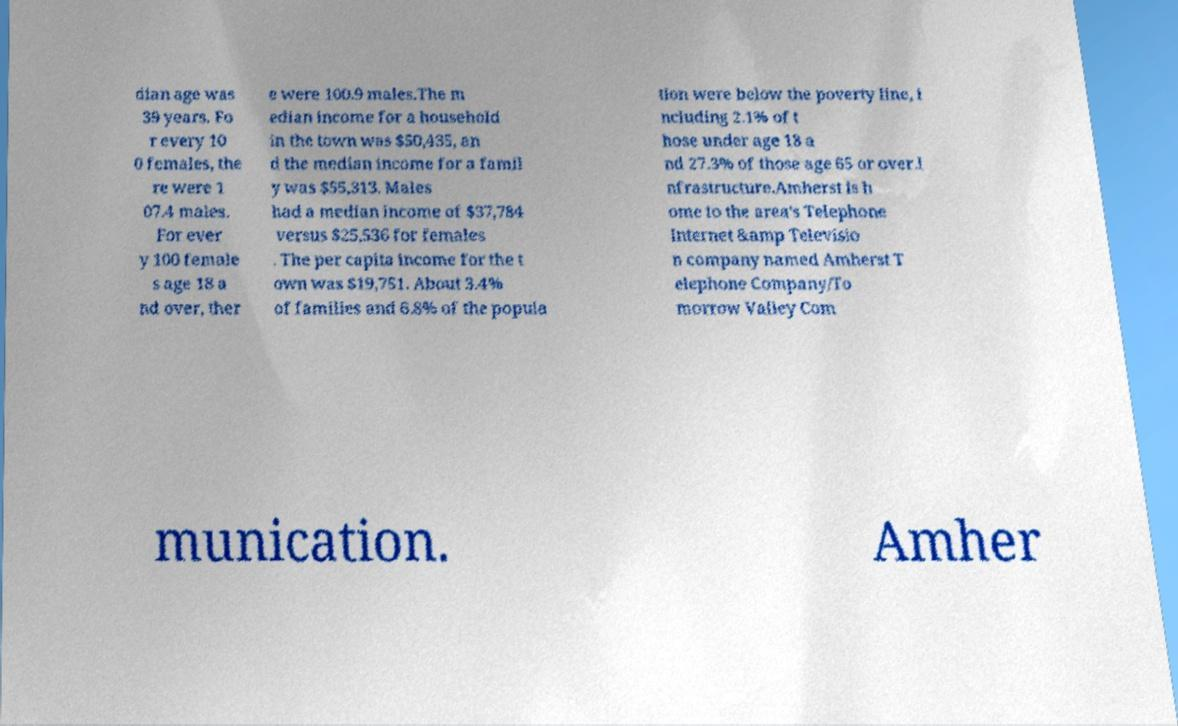Can you accurately transcribe the text from the provided image for me? dian age was 39 years. Fo r every 10 0 females, the re were 1 07.4 males. For ever y 100 female s age 18 a nd over, ther e were 100.9 males.The m edian income for a household in the town was $50,435, an d the median income for a famil y was $55,313. Males had a median income of $37,784 versus $25,536 for females . The per capita income for the t own was $19,751. About 3.4% of families and 6.8% of the popula tion were below the poverty line, i ncluding 2.1% of t hose under age 18 a nd 27.3% of those age 65 or over.I nfrastructure.Amherst is h ome to the area's Telephone Internet &amp Televisio n company named Amherst T elephone Company/To morrow Valley Com munication. Amher 